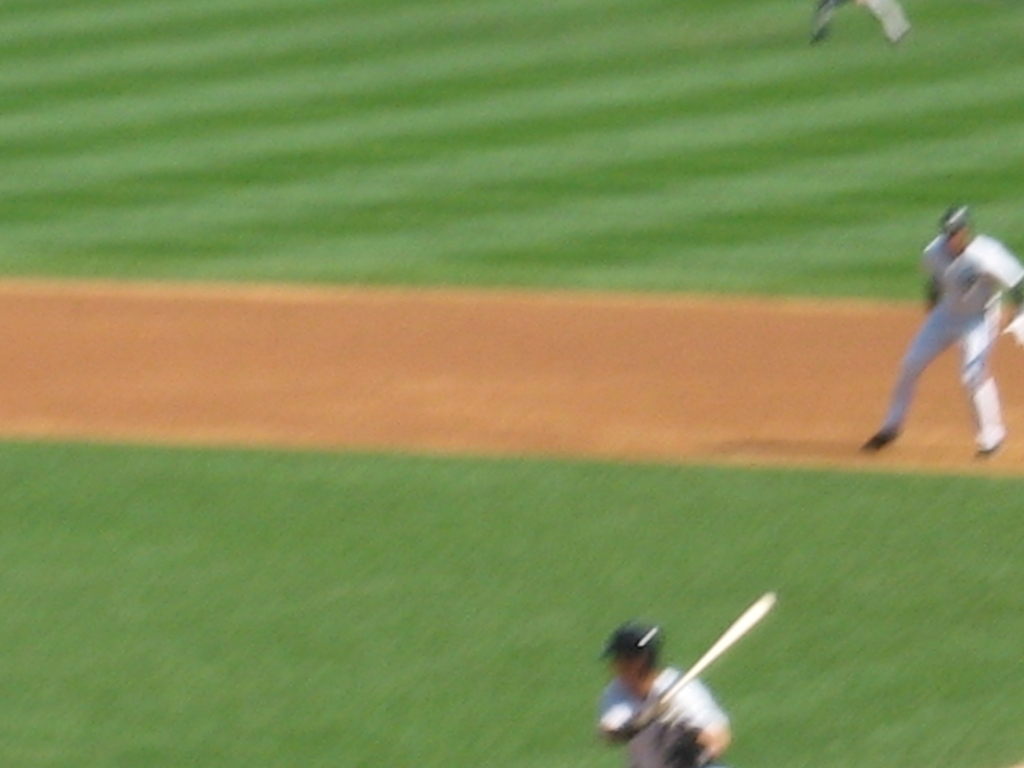How would you describe the exposure of this image? The image appears to be overexposed, resulting in a washout of fine details. Additionally, there is motion blur, likely due to the fast movement within the scene and a slower shutter speed, which contributes to the overall poor quality of the photograph. 